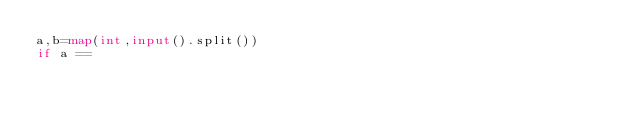<code> <loc_0><loc_0><loc_500><loc_500><_Python_>a,b=map(int,input().split())
if a == </code> 